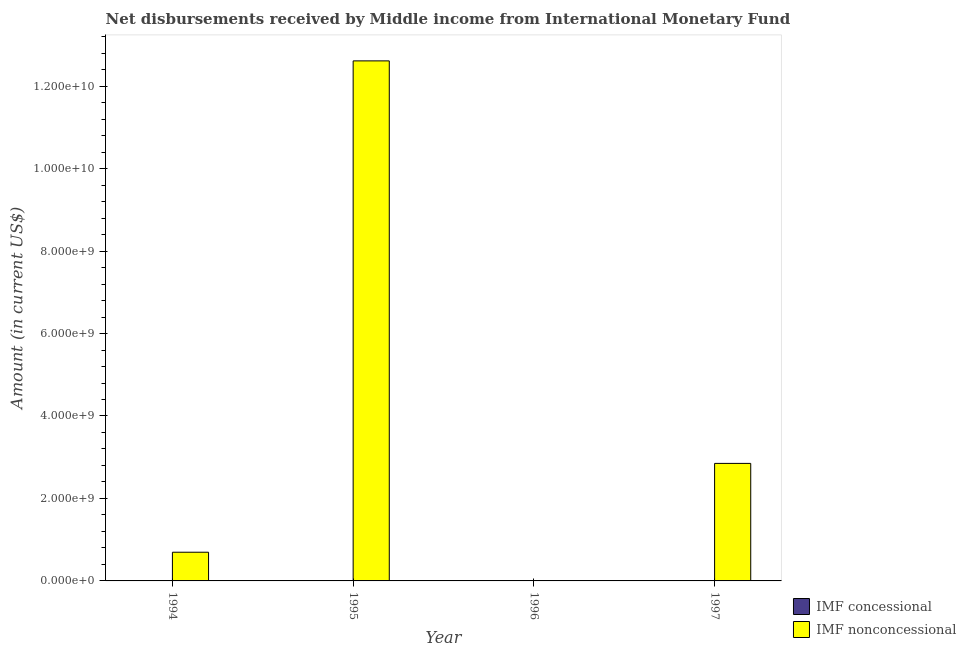Are the number of bars per tick equal to the number of legend labels?
Ensure brevity in your answer.  No. How many bars are there on the 3rd tick from the right?
Provide a short and direct response. 1. What is the label of the 1st group of bars from the left?
Provide a succinct answer. 1994. In how many cases, is the number of bars for a given year not equal to the number of legend labels?
Offer a terse response. 4. What is the net non concessional disbursements from imf in 1995?
Provide a succinct answer. 1.26e+1. Across all years, what is the maximum net non concessional disbursements from imf?
Offer a very short reply. 1.26e+1. In which year was the net non concessional disbursements from imf maximum?
Make the answer very short. 1995. What is the difference between the net non concessional disbursements from imf in 1994 and that in 1997?
Your answer should be very brief. -2.15e+09. What is the difference between the net concessional disbursements from imf in 1994 and the net non concessional disbursements from imf in 1996?
Give a very brief answer. 0. What is the ratio of the net non concessional disbursements from imf in 1995 to that in 1997?
Make the answer very short. 4.43. Is the net non concessional disbursements from imf in 1994 less than that in 1995?
Your answer should be compact. Yes. What is the difference between the highest and the second highest net non concessional disbursements from imf?
Your answer should be compact. 9.76e+09. What is the difference between the highest and the lowest net non concessional disbursements from imf?
Offer a very short reply. 1.26e+1. In how many years, is the net non concessional disbursements from imf greater than the average net non concessional disbursements from imf taken over all years?
Ensure brevity in your answer.  1. Is the sum of the net non concessional disbursements from imf in 1995 and 1997 greater than the maximum net concessional disbursements from imf across all years?
Make the answer very short. Yes. Are all the bars in the graph horizontal?
Your answer should be compact. No. How many years are there in the graph?
Ensure brevity in your answer.  4. What is the difference between two consecutive major ticks on the Y-axis?
Make the answer very short. 2.00e+09. How many legend labels are there?
Your answer should be very brief. 2. How are the legend labels stacked?
Your answer should be compact. Vertical. What is the title of the graph?
Keep it short and to the point. Net disbursements received by Middle income from International Monetary Fund. Does "From Government" appear as one of the legend labels in the graph?
Your answer should be very brief. No. What is the label or title of the X-axis?
Provide a short and direct response. Year. What is the Amount (in current US$) of IMF concessional in 1994?
Provide a short and direct response. 0. What is the Amount (in current US$) in IMF nonconcessional in 1994?
Offer a terse response. 6.96e+08. What is the Amount (in current US$) of IMF concessional in 1995?
Your response must be concise. 0. What is the Amount (in current US$) of IMF nonconcessional in 1995?
Offer a very short reply. 1.26e+1. What is the Amount (in current US$) of IMF nonconcessional in 1997?
Your response must be concise. 2.85e+09. Across all years, what is the maximum Amount (in current US$) in IMF nonconcessional?
Offer a terse response. 1.26e+1. What is the total Amount (in current US$) of IMF nonconcessional in the graph?
Keep it short and to the point. 1.62e+1. What is the difference between the Amount (in current US$) of IMF nonconcessional in 1994 and that in 1995?
Offer a terse response. -1.19e+1. What is the difference between the Amount (in current US$) in IMF nonconcessional in 1994 and that in 1997?
Your answer should be compact. -2.15e+09. What is the difference between the Amount (in current US$) of IMF nonconcessional in 1995 and that in 1997?
Offer a very short reply. 9.76e+09. What is the average Amount (in current US$) of IMF concessional per year?
Your answer should be very brief. 0. What is the average Amount (in current US$) of IMF nonconcessional per year?
Give a very brief answer. 4.04e+09. What is the ratio of the Amount (in current US$) in IMF nonconcessional in 1994 to that in 1995?
Give a very brief answer. 0.06. What is the ratio of the Amount (in current US$) of IMF nonconcessional in 1994 to that in 1997?
Your answer should be compact. 0.24. What is the ratio of the Amount (in current US$) in IMF nonconcessional in 1995 to that in 1997?
Your answer should be very brief. 4.43. What is the difference between the highest and the second highest Amount (in current US$) of IMF nonconcessional?
Offer a terse response. 9.76e+09. What is the difference between the highest and the lowest Amount (in current US$) of IMF nonconcessional?
Your answer should be very brief. 1.26e+1. 